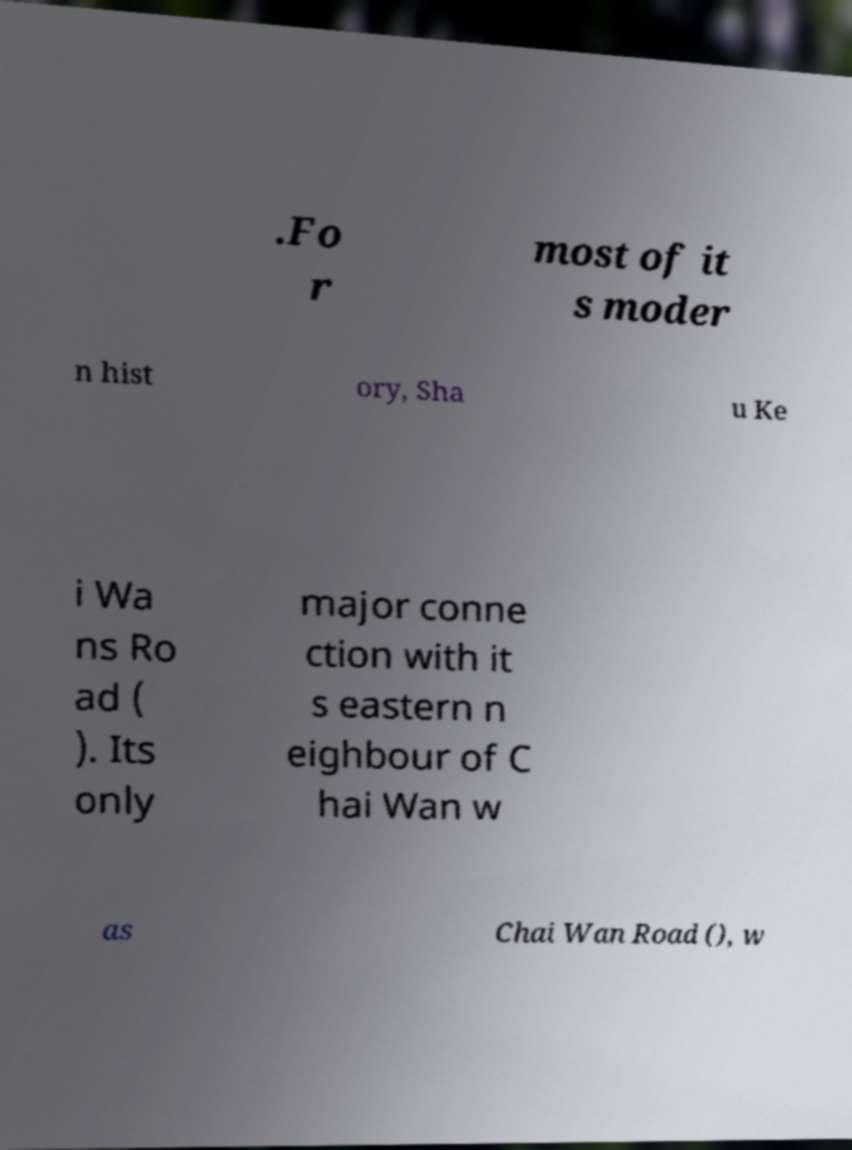What messages or text are displayed in this image? I need them in a readable, typed format. .Fo r most of it s moder n hist ory, Sha u Ke i Wa ns Ro ad ( ). Its only major conne ction with it s eastern n eighbour of C hai Wan w as Chai Wan Road (), w 